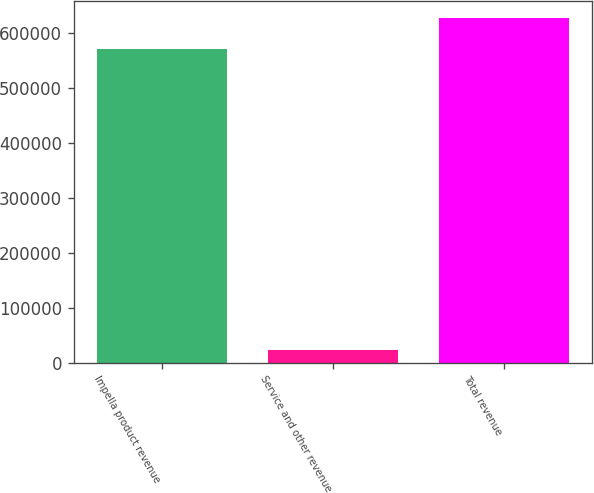Convert chart. <chart><loc_0><loc_0><loc_500><loc_500><bar_chart><fcel>Impella product revenue<fcel>Service and other revenue<fcel>Total revenue<nl><fcel>570870<fcel>22879<fcel>627957<nl></chart> 